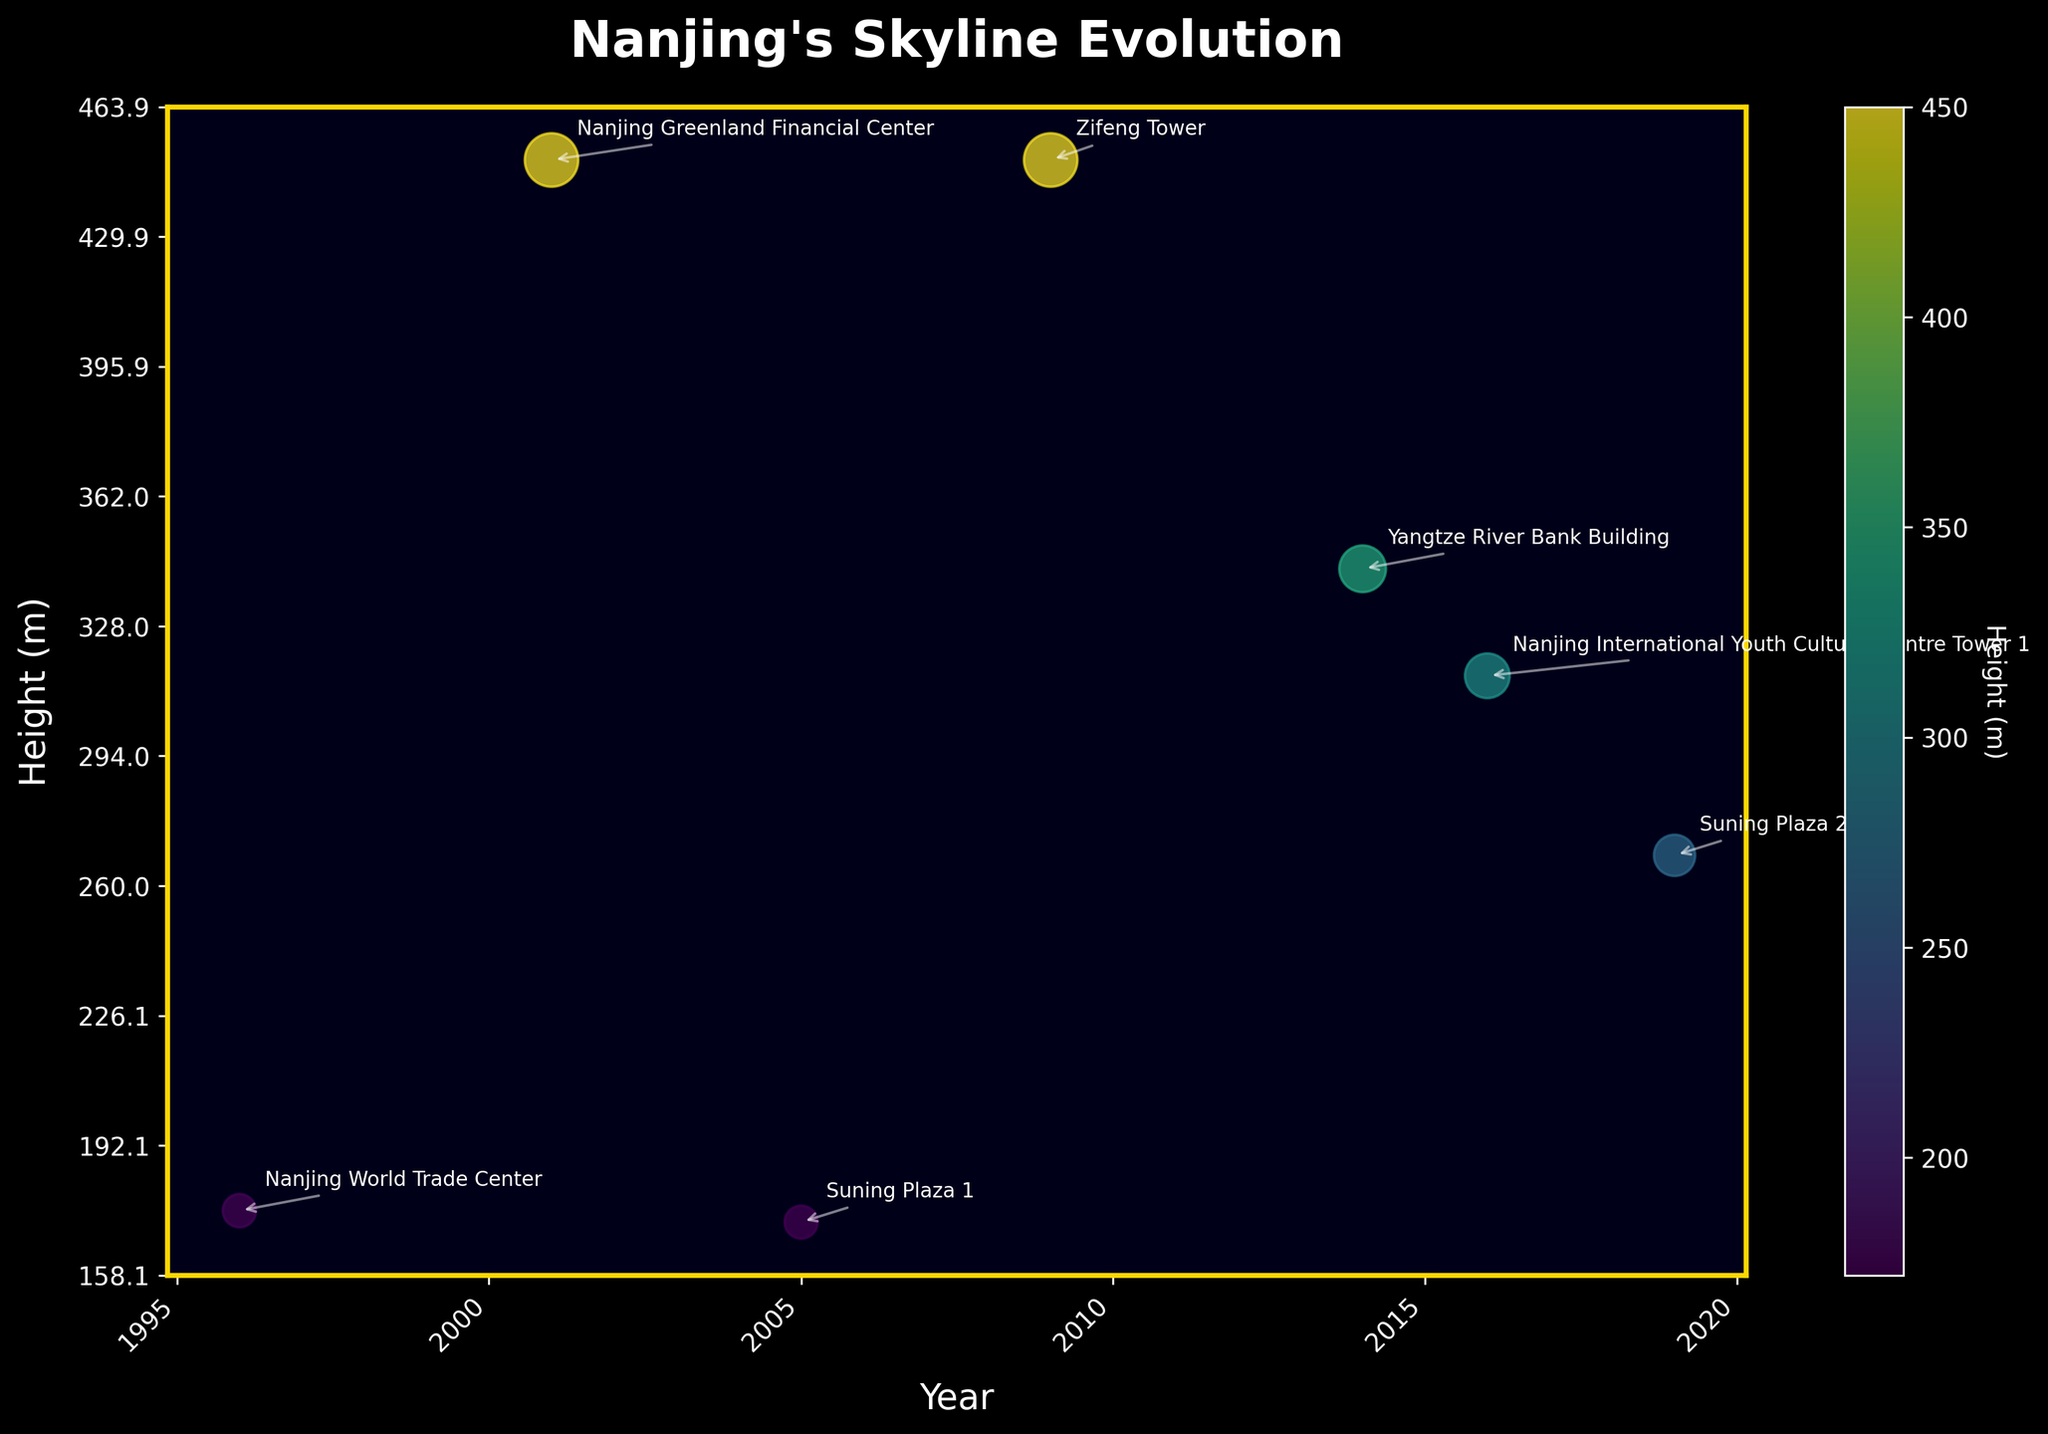What's the title of the plot? The title is usually at the top of the plot and indicates what the plot is about. Here, it reads "Nanjing's Skyline Evolution".
Answer: Nanjing's Skyline Evolution How many landmarks are represented in the figure? Count the data points or the labels annotated near the points. There are 7 landmarks in total.
Answer: 7 Which landmark is currently the tallest building in Nanjing? According to the annotations, Zifeng Tower, completed in 2009, is the tallest building at 450 meters.
Answer: Zifeng Tower What's the height difference between the Nanjing Greenland Financial Center and Suning Plaza 2? Look at the heights from the annotations: Nanjing Greenland Financial Center is 450 meters and Suning Plaza 2 is 268 meters. The difference is 450-268.
Answer: 182 meters In which year was the Nanjing International Youth Cultural Centre Tower 1 completed? Identify the corresponding point for the Nanjing International Youth Cultural Centre Tower 1, which is annotated next to the year 2016.
Answer: 2016 What is the average height of the buildings constructed between 1996 and 2009? The buildings are Nanjing World Trade Center (175m), Nanjing Greenland Financial Center (450m), Suning Plaza 1 (172m), and Zifeng Tower (450m). The average is calculated as (175 + 450 + 172 + 450) / 4.
Answer: 311.75 meters Which two buildings share the same height and what is it? Based on the annotations, Nanjing Greenland Financial Center and Zifeng Tower both have a height of 450 meters.
Answer: Nanjing Greenland Financial Center and Zifeng Tower, 450 meters How has the height of buildings evolved over the years? Observing the plot, the heights of the buildings generally increased over the years with some variation. The plot shows taller buildings being constructed in later years, suggesting a trend towards building higher structures over time.
Answer: Generally increased What's the median height of all the landmarks shown? Listing the heights in order: 172, 175, 268, 315, 343, 450, 450. The median is the middle value of the ordered list, which is 315 meters.
Answer: 315 meters Which landmark was designed by a famous architect and what's its height? From the annotations, the Nanjing International Youth Cultural Centre Tower 1 is noted to be designed by Zaha Hadid, and its height is 315 meters.
Answer: Nanjing International Youth Cultural Centre Tower 1, 315 meters 